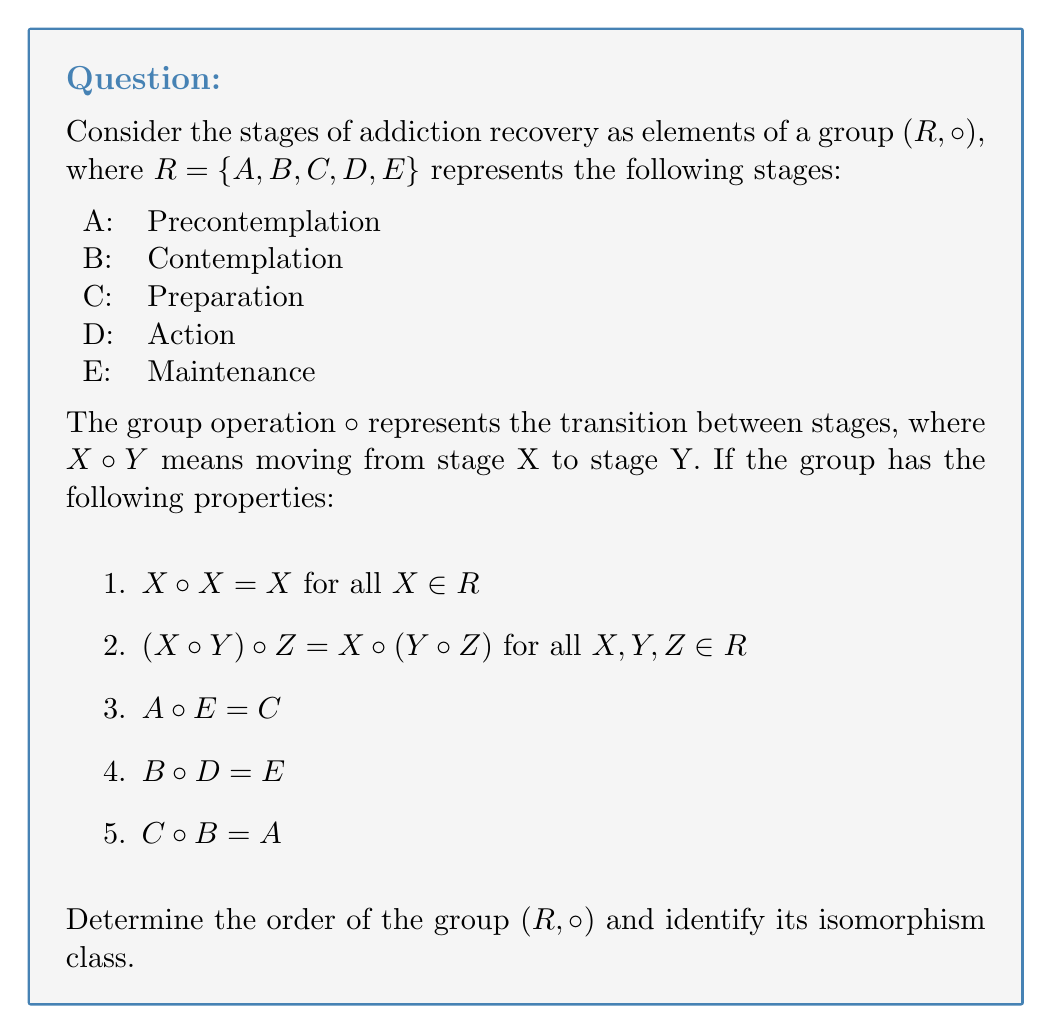Can you solve this math problem? To solve this problem, we need to analyze the group structure based on the given information and determine its properties. Let's approach this step-by-step:

1. First, we need to understand what the given properties mean:
   - Property 1 indicates that staying in the same stage is an identity operation.
   - Property 2 shows that the operation is associative.
   - Properties 3, 4, and 5 give us specific relationships between elements.

2. To determine the order of the group, we need to count the number of distinct elements. In this case, we have 5 elements: $|R| = 5$.

3. Now, let's consider the structure of the group. With 5 elements, the possible group structures are:
   - Cyclic group of order 5: $C_5$
   - Direct product of cyclic groups: $C_2 \times C_3$

4. To determine which structure our group has, we need to find the order of each element:
   - From property 1, we know that $X \circ X = X$ for all $X$, which means every element has order 1 or 2.
   - If any element had order 5, it would generate the entire group, making it cyclic. However, this contradicts property 1.

5. Therefore, our group cannot be $C_5$. It must be isomorphic to $C_2 \times C_3$.

6. To confirm this, we can try to find elements of order 2 and 3:
   - Elements of order 2 would satisfy $X \circ X = X$ (which all elements do)
   - Elements of order 3 would satisfy $X \circ X \circ X = X$

7. While we don't have enough information to explicitly construct the entire operation table, the given properties are consistent with the structure of $C_2 \times C_3$.

8. The group $C_2 \times C_3$ has the following properties:
   - It has 6 elements in total
   - It has 3 elements of order 2
   - It has 2 elements of order 3
   - It has 1 identity element

9. Our group $(R, \circ)$ satisfies these properties, with the identity element being implicitly defined by property 1.
Answer: The order of the group $(R, \circ)$ is 5, and it is isomorphic to $C_2 \times C_3$. 